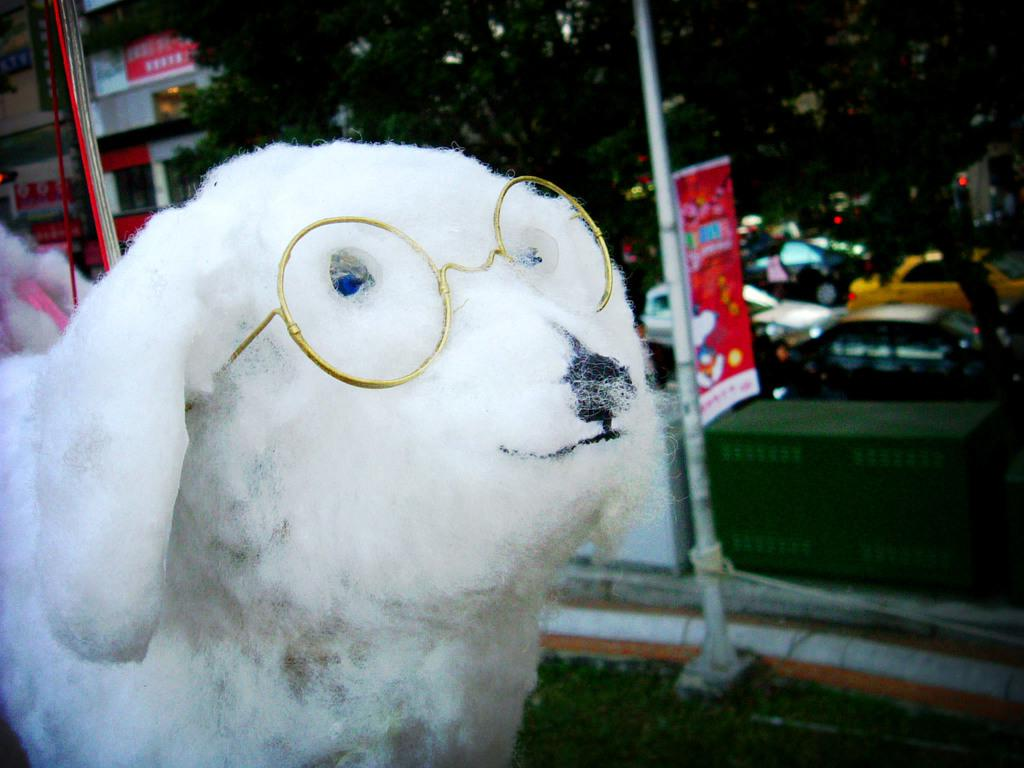What type of doll is in the image? There is a doll in the shape of a dog in the image. What can be seen in the background of the image? There are vehicles, trees, and buildings in the background of the image. What is located in the middle of the image? There appears to be a banner in the middle of the image. What type of muscle is being flexed by the dog in the image? There is no dog in the image, only a doll in the shape of a dog. Additionally, the doll is not flexing any muscles. 